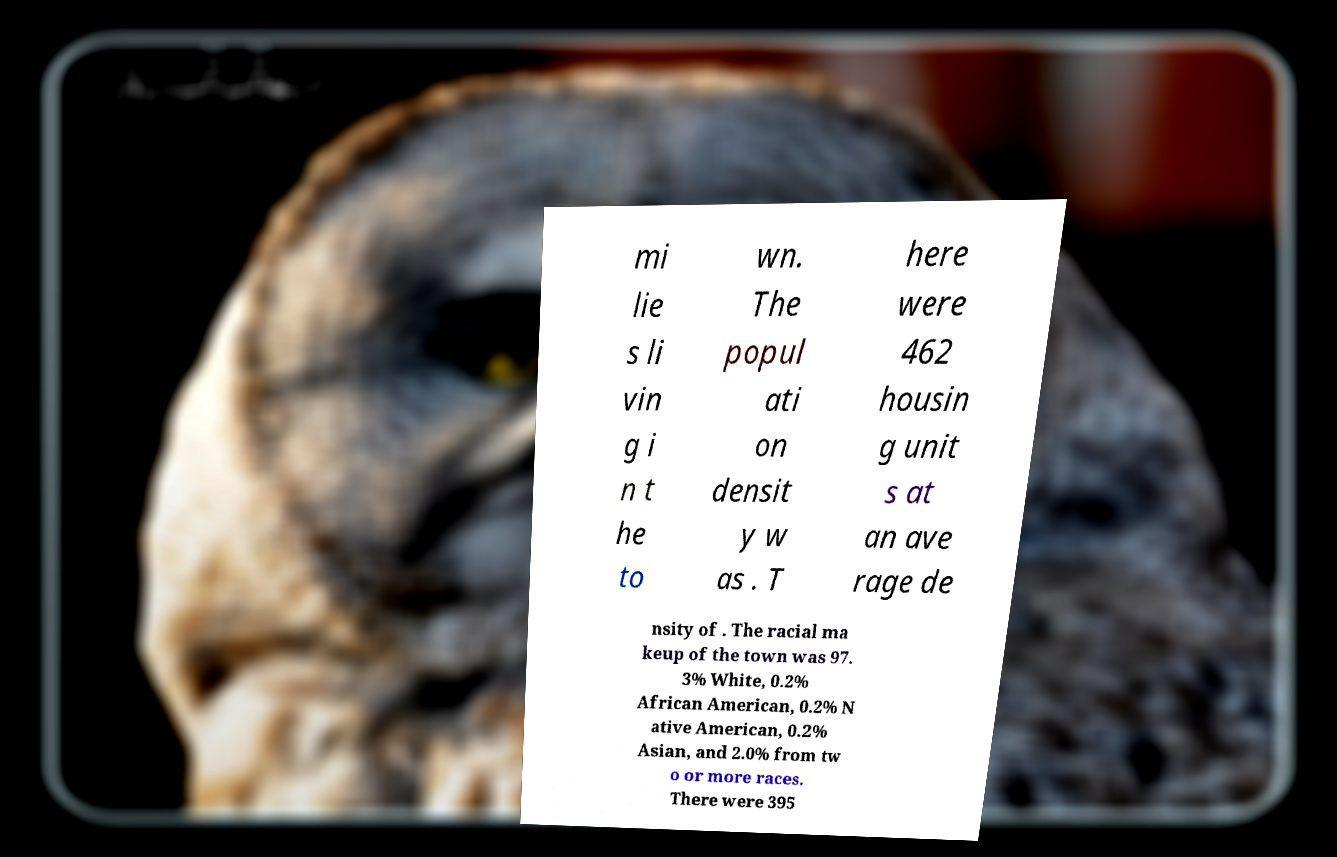For documentation purposes, I need the text within this image transcribed. Could you provide that? mi lie s li vin g i n t he to wn. The popul ati on densit y w as . T here were 462 housin g unit s at an ave rage de nsity of . The racial ma keup of the town was 97. 3% White, 0.2% African American, 0.2% N ative American, 0.2% Asian, and 2.0% from tw o or more races. There were 395 